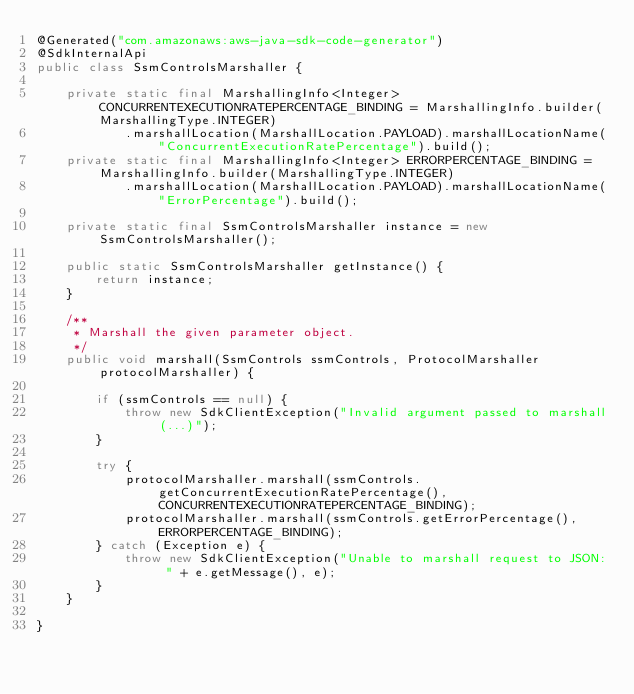<code> <loc_0><loc_0><loc_500><loc_500><_Java_>@Generated("com.amazonaws:aws-java-sdk-code-generator")
@SdkInternalApi
public class SsmControlsMarshaller {

    private static final MarshallingInfo<Integer> CONCURRENTEXECUTIONRATEPERCENTAGE_BINDING = MarshallingInfo.builder(MarshallingType.INTEGER)
            .marshallLocation(MarshallLocation.PAYLOAD).marshallLocationName("ConcurrentExecutionRatePercentage").build();
    private static final MarshallingInfo<Integer> ERRORPERCENTAGE_BINDING = MarshallingInfo.builder(MarshallingType.INTEGER)
            .marshallLocation(MarshallLocation.PAYLOAD).marshallLocationName("ErrorPercentage").build();

    private static final SsmControlsMarshaller instance = new SsmControlsMarshaller();

    public static SsmControlsMarshaller getInstance() {
        return instance;
    }

    /**
     * Marshall the given parameter object.
     */
    public void marshall(SsmControls ssmControls, ProtocolMarshaller protocolMarshaller) {

        if (ssmControls == null) {
            throw new SdkClientException("Invalid argument passed to marshall(...)");
        }

        try {
            protocolMarshaller.marshall(ssmControls.getConcurrentExecutionRatePercentage(), CONCURRENTEXECUTIONRATEPERCENTAGE_BINDING);
            protocolMarshaller.marshall(ssmControls.getErrorPercentage(), ERRORPERCENTAGE_BINDING);
        } catch (Exception e) {
            throw new SdkClientException("Unable to marshall request to JSON: " + e.getMessage(), e);
        }
    }

}
</code> 